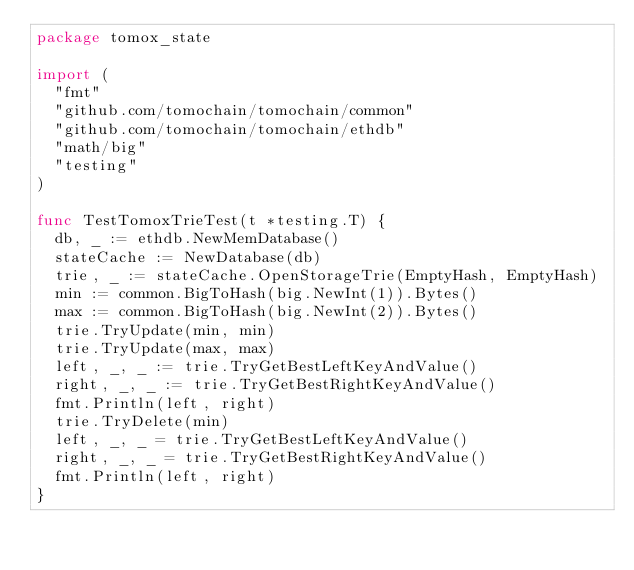Convert code to text. <code><loc_0><loc_0><loc_500><loc_500><_Go_>package tomox_state

import (
	"fmt"
	"github.com/tomochain/tomochain/common"
	"github.com/tomochain/tomochain/ethdb"
	"math/big"
	"testing"
)

func TestTomoxTrieTest(t *testing.T) {
	db, _ := ethdb.NewMemDatabase()
	stateCache := NewDatabase(db)
	trie, _ := stateCache.OpenStorageTrie(EmptyHash, EmptyHash)
	min := common.BigToHash(big.NewInt(1)).Bytes()
	max := common.BigToHash(big.NewInt(2)).Bytes()
	trie.TryUpdate(min, min)
	trie.TryUpdate(max, max)
	left, _, _ := trie.TryGetBestLeftKeyAndValue()
	right, _, _ := trie.TryGetBestRightKeyAndValue()
	fmt.Println(left, right)
	trie.TryDelete(min)
	left, _, _ = trie.TryGetBestLeftKeyAndValue()
	right, _, _ = trie.TryGetBestRightKeyAndValue()
	fmt.Println(left, right)
}
</code> 